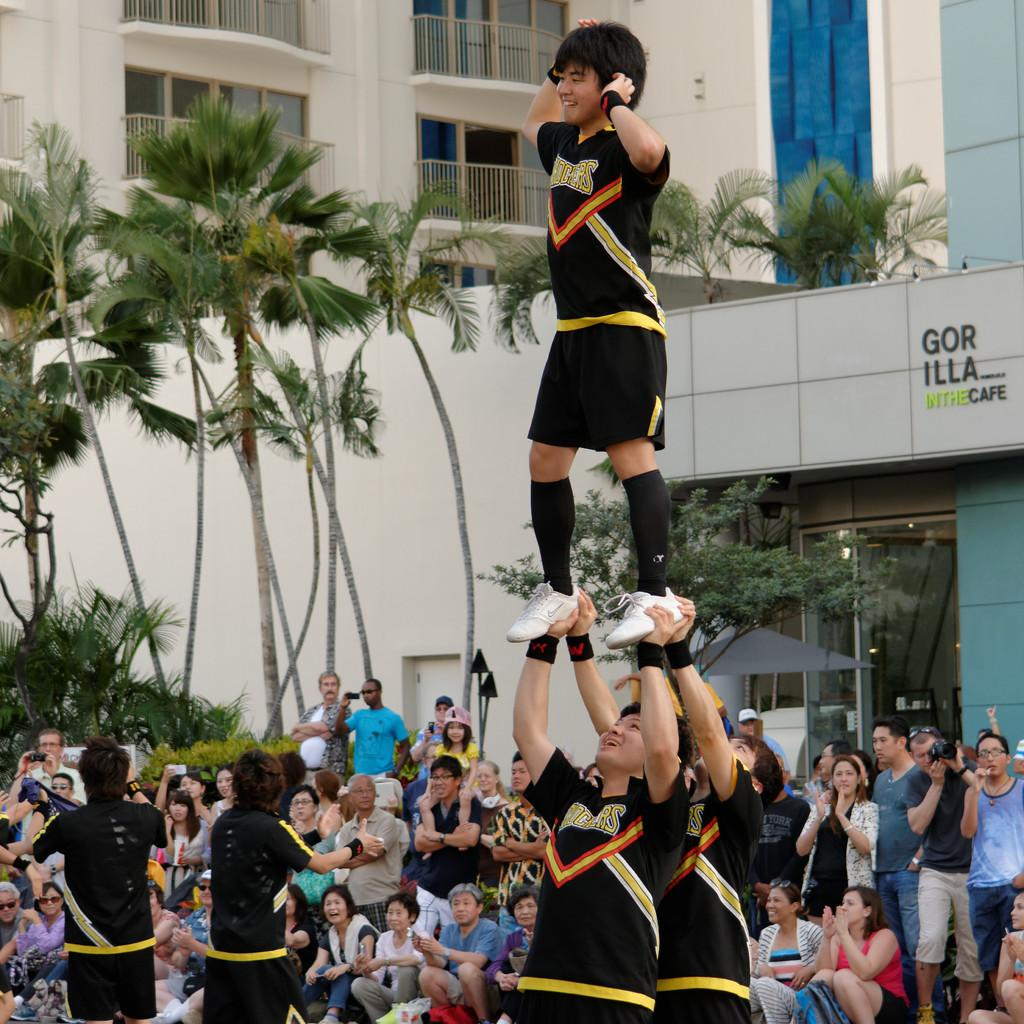<image>
Render a clear and concise summary of the photo. Person standing on the hands of another person in front of a cafe that says "Gorilla". 